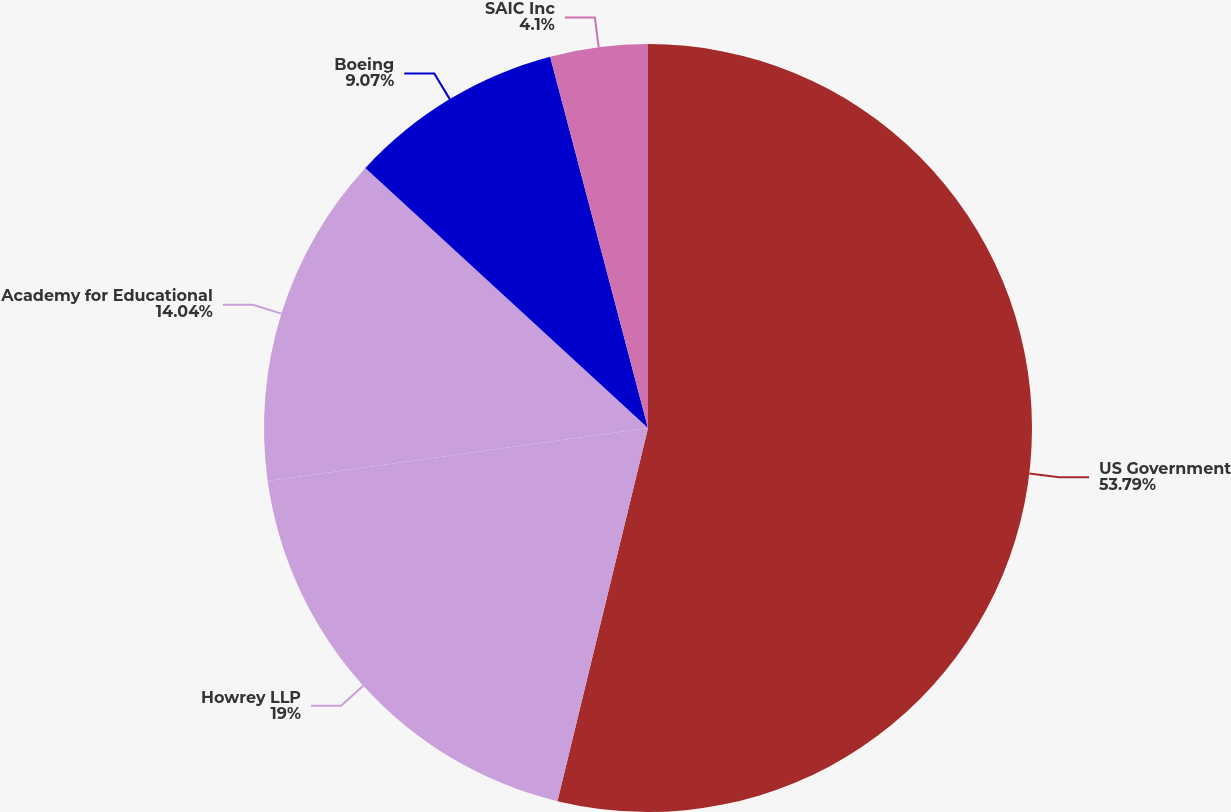<chart> <loc_0><loc_0><loc_500><loc_500><pie_chart><fcel>US Government<fcel>Howrey LLP<fcel>Academy for Educational<fcel>Boeing<fcel>SAIC Inc<nl><fcel>53.8%<fcel>19.01%<fcel>14.04%<fcel>9.07%<fcel>4.1%<nl></chart> 